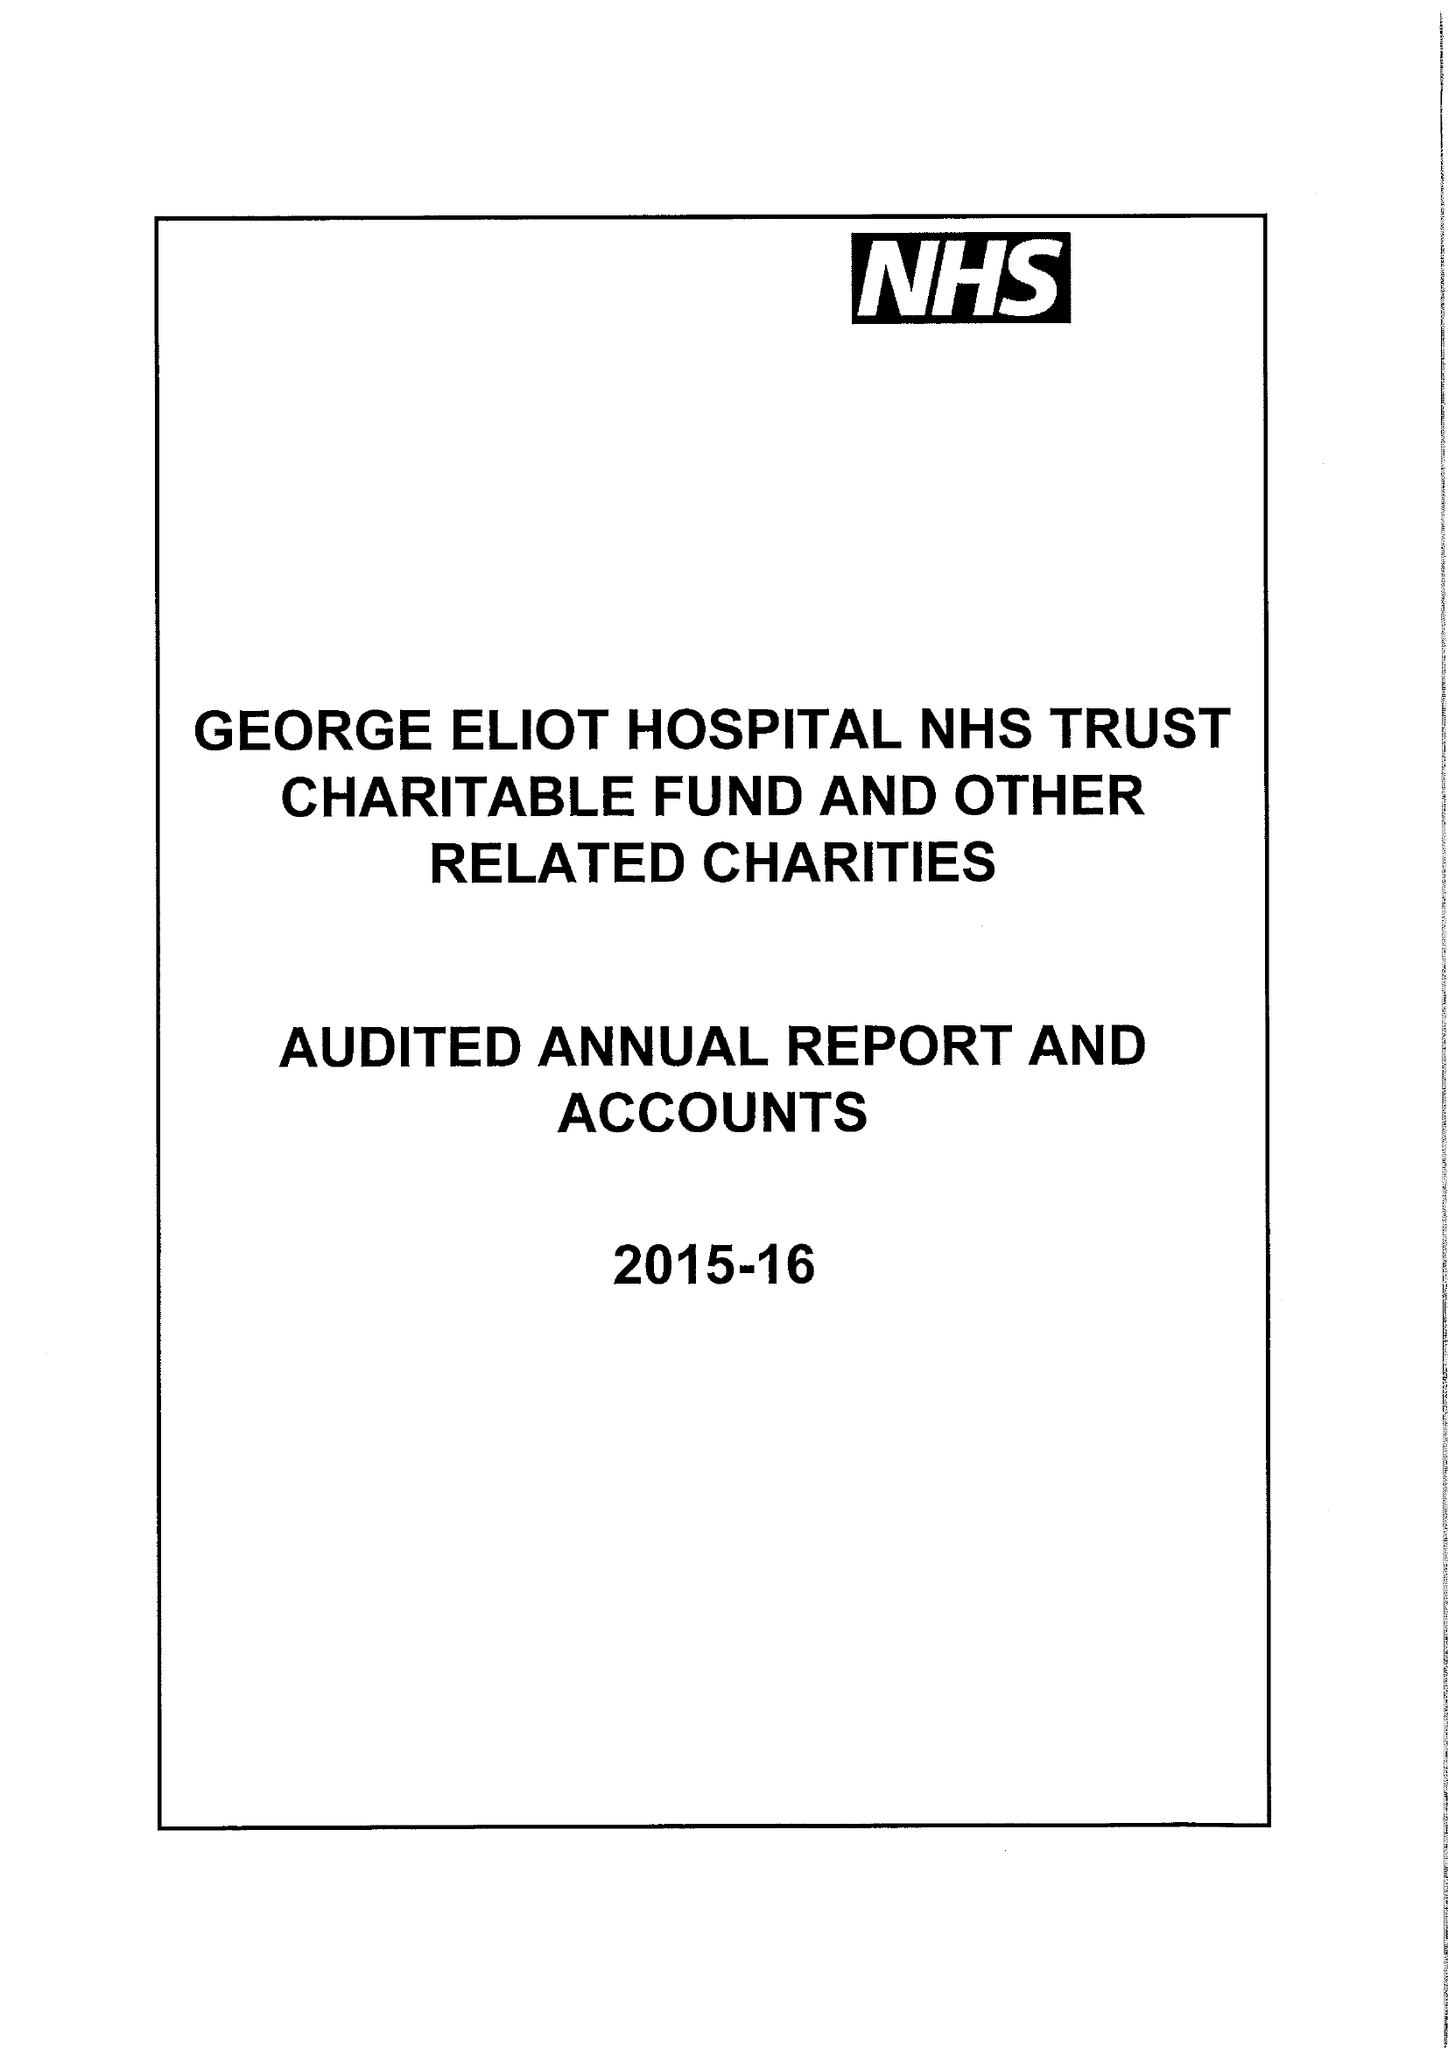What is the value for the charity_name?
Answer the question using a single word or phrase. George Eliot Hospital Nhs Trust Charitable Fund and Other Related Charities 